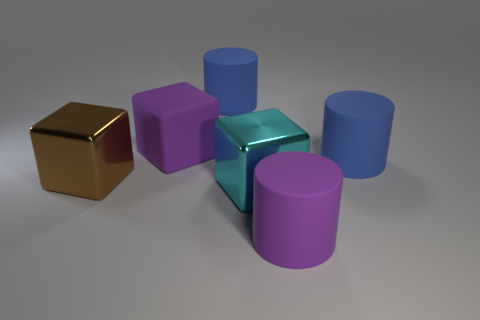Are there any other things that are the same material as the brown block?
Offer a terse response. Yes. What is the material of the brown object that is the same shape as the cyan thing?
Offer a terse response. Metal. Is there a large purple block made of the same material as the large purple cylinder?
Ensure brevity in your answer.  Yes. Does the big purple thing that is behind the big brown shiny cube have the same material as the big purple cylinder?
Make the answer very short. Yes. Are there more big things to the left of the big cyan shiny block than purple matte objects that are behind the brown thing?
Keep it short and to the point. Yes. What color is the other rubber block that is the same size as the cyan cube?
Give a very brief answer. Purple. Is there a large rubber object that has the same color as the matte block?
Provide a short and direct response. Yes. Is the color of the big matte cylinder that is behind the rubber block the same as the thing that is to the right of the large purple rubber cylinder?
Make the answer very short. Yes. What material is the blue thing behind the big purple block?
Your answer should be very brief. Rubber. What is the color of the large block that is made of the same material as the purple cylinder?
Provide a succinct answer. Purple. 